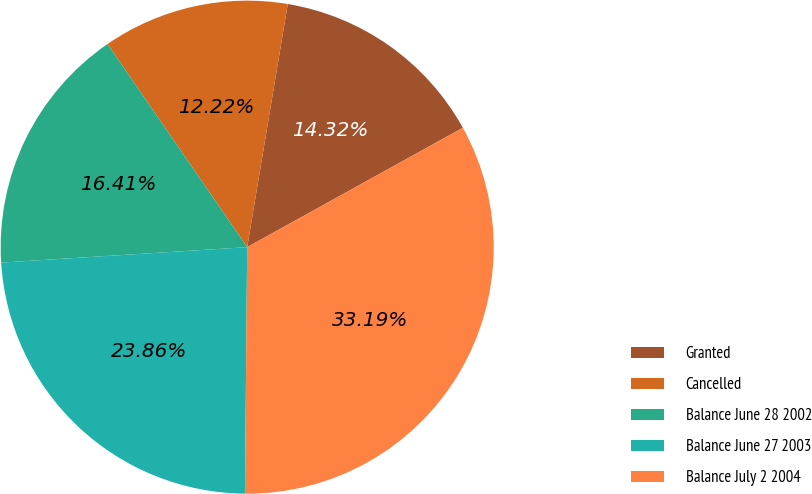Convert chart. <chart><loc_0><loc_0><loc_500><loc_500><pie_chart><fcel>Granted<fcel>Cancelled<fcel>Balance June 28 2002<fcel>Balance June 27 2003<fcel>Balance July 2 2004<nl><fcel>14.32%<fcel>12.22%<fcel>16.41%<fcel>23.86%<fcel>33.19%<nl></chart> 